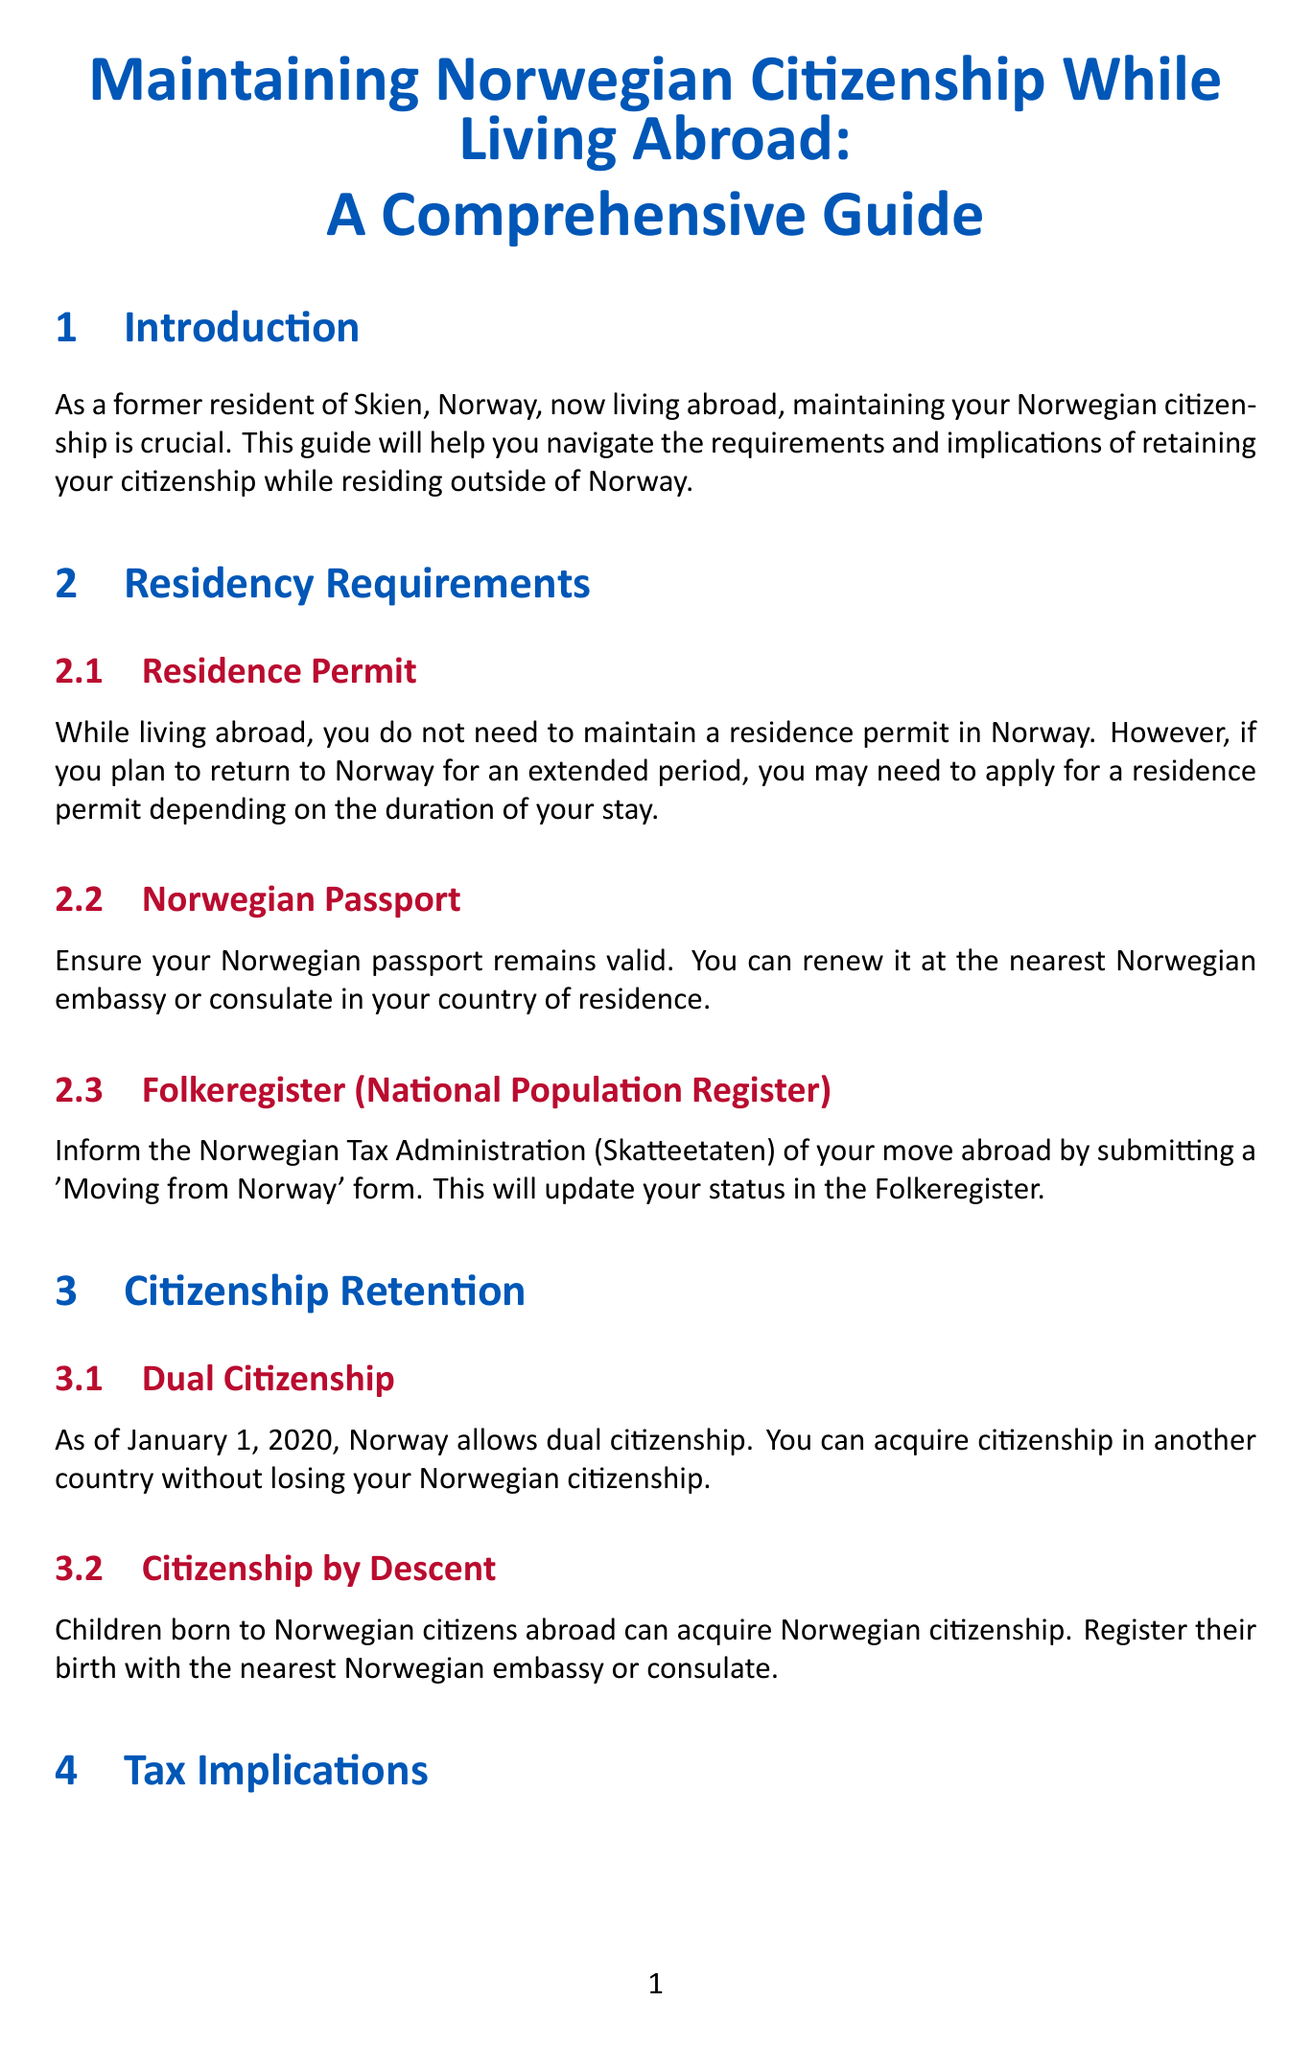What is the title of the guide? The title of the guide is presented at the beginning of the document, capturing its overall theme.
Answer: Maintaining Norwegian Citizenship While Living Abroad: A Comprehensive Guide What should you inform the Tax Administration about? One of the key residency requirements includes a mandate to inform the Tax Administration when relocating abroad.
Answer: Move abroad When was dual citizenship allowed in Norway? This information explains a significant change in the citizenship laws in Norway, specifically related to dual citizenship.
Answer: January 1, 2020 What tax form is used to report income? The document specifies the tax form required for residents to report their income, indicating its importance in tax compliance.
Answer: RF-1030 Where can you renew your Norwegian passport? The guide specifies the locations where necessary services, such as passport renewal, can be obtained while living abroad.
Answer: Nearest Norwegian embassy or consulate What is affected by living abroad? The document outlines several implications of living outside Norway, including statutory obligations and rights related to Norwegian systems.
Answer: Membership in Folketrygden Can you vote in national elections while abroad? The voting rights section details the conditions under which voting rights are retained for citizens residing outside Norway.
Answer: Yes What should you do upon returning to Norway? The returning section provides essential steps for re-establishing residency in Norway after living abroad.
Answer: Re-register with the Folkeregister 